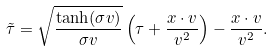<formula> <loc_0><loc_0><loc_500><loc_500>\tilde { \tau } = \sqrt { \frac { \tanh ( \sigma v ) } { \sigma v } } \left ( \tau + \frac { x \cdot v } { v ^ { 2 } } \right ) - \frac { x \cdot v } { v ^ { 2 } } .</formula> 